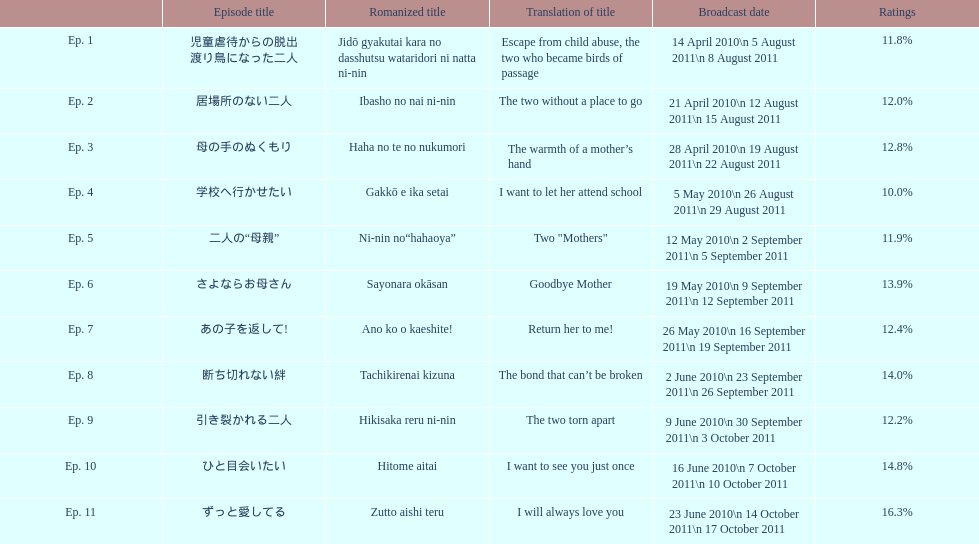How many episodes are there in total? 11. 